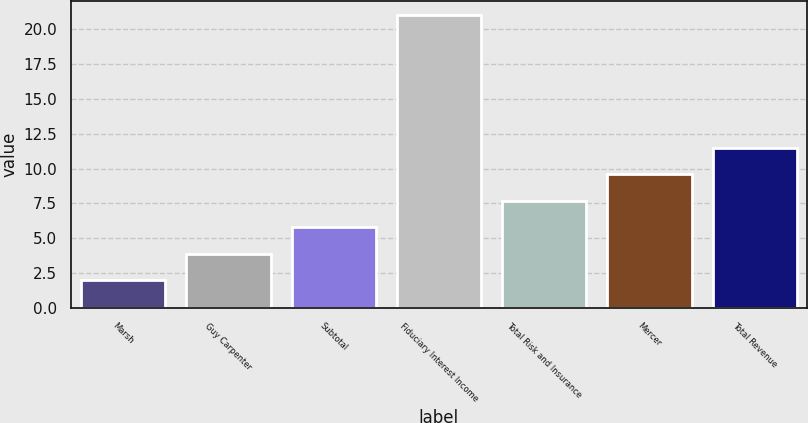<chart> <loc_0><loc_0><loc_500><loc_500><bar_chart><fcel>Marsh<fcel>Guy Carpenter<fcel>Subtotal<fcel>Fiduciary Interest Income<fcel>Total Risk and Insurance<fcel>Mercer<fcel>Total Revenue<nl><fcel>2<fcel>3.9<fcel>5.8<fcel>21<fcel>7.7<fcel>9.6<fcel>11.5<nl></chart> 